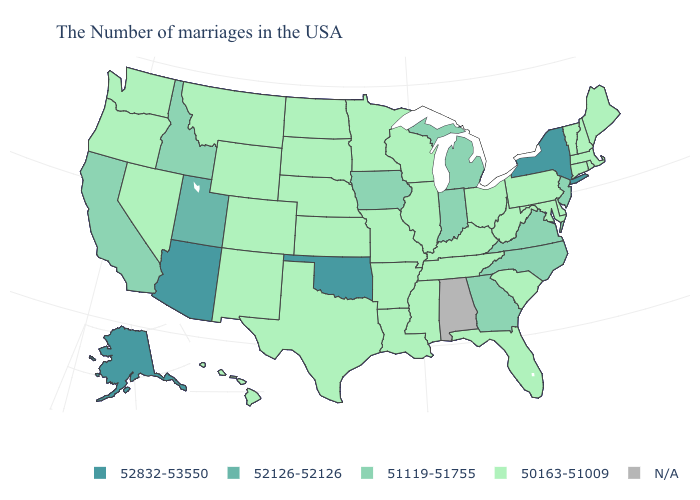Which states have the highest value in the USA?
Answer briefly. New York, Oklahoma, Arizona, Alaska. Which states have the lowest value in the USA?
Keep it brief. Maine, Massachusetts, Rhode Island, New Hampshire, Vermont, Connecticut, Delaware, Maryland, Pennsylvania, South Carolina, West Virginia, Ohio, Florida, Kentucky, Tennessee, Wisconsin, Illinois, Mississippi, Louisiana, Missouri, Arkansas, Minnesota, Kansas, Nebraska, Texas, South Dakota, North Dakota, Wyoming, Colorado, New Mexico, Montana, Nevada, Washington, Oregon, Hawaii. What is the value of Mississippi?
Quick response, please. 50163-51009. What is the highest value in the MidWest ?
Give a very brief answer. 51119-51755. Among the states that border Alabama , which have the lowest value?
Be succinct. Florida, Tennessee, Mississippi. Does the map have missing data?
Be succinct. Yes. Does Arizona have the highest value in the USA?
Concise answer only. Yes. Name the states that have a value in the range 50163-51009?
Answer briefly. Maine, Massachusetts, Rhode Island, New Hampshire, Vermont, Connecticut, Delaware, Maryland, Pennsylvania, South Carolina, West Virginia, Ohio, Florida, Kentucky, Tennessee, Wisconsin, Illinois, Mississippi, Louisiana, Missouri, Arkansas, Minnesota, Kansas, Nebraska, Texas, South Dakota, North Dakota, Wyoming, Colorado, New Mexico, Montana, Nevada, Washington, Oregon, Hawaii. Which states have the lowest value in the MidWest?
Write a very short answer. Ohio, Wisconsin, Illinois, Missouri, Minnesota, Kansas, Nebraska, South Dakota, North Dakota. Does Utah have the highest value in the West?
Short answer required. No. 